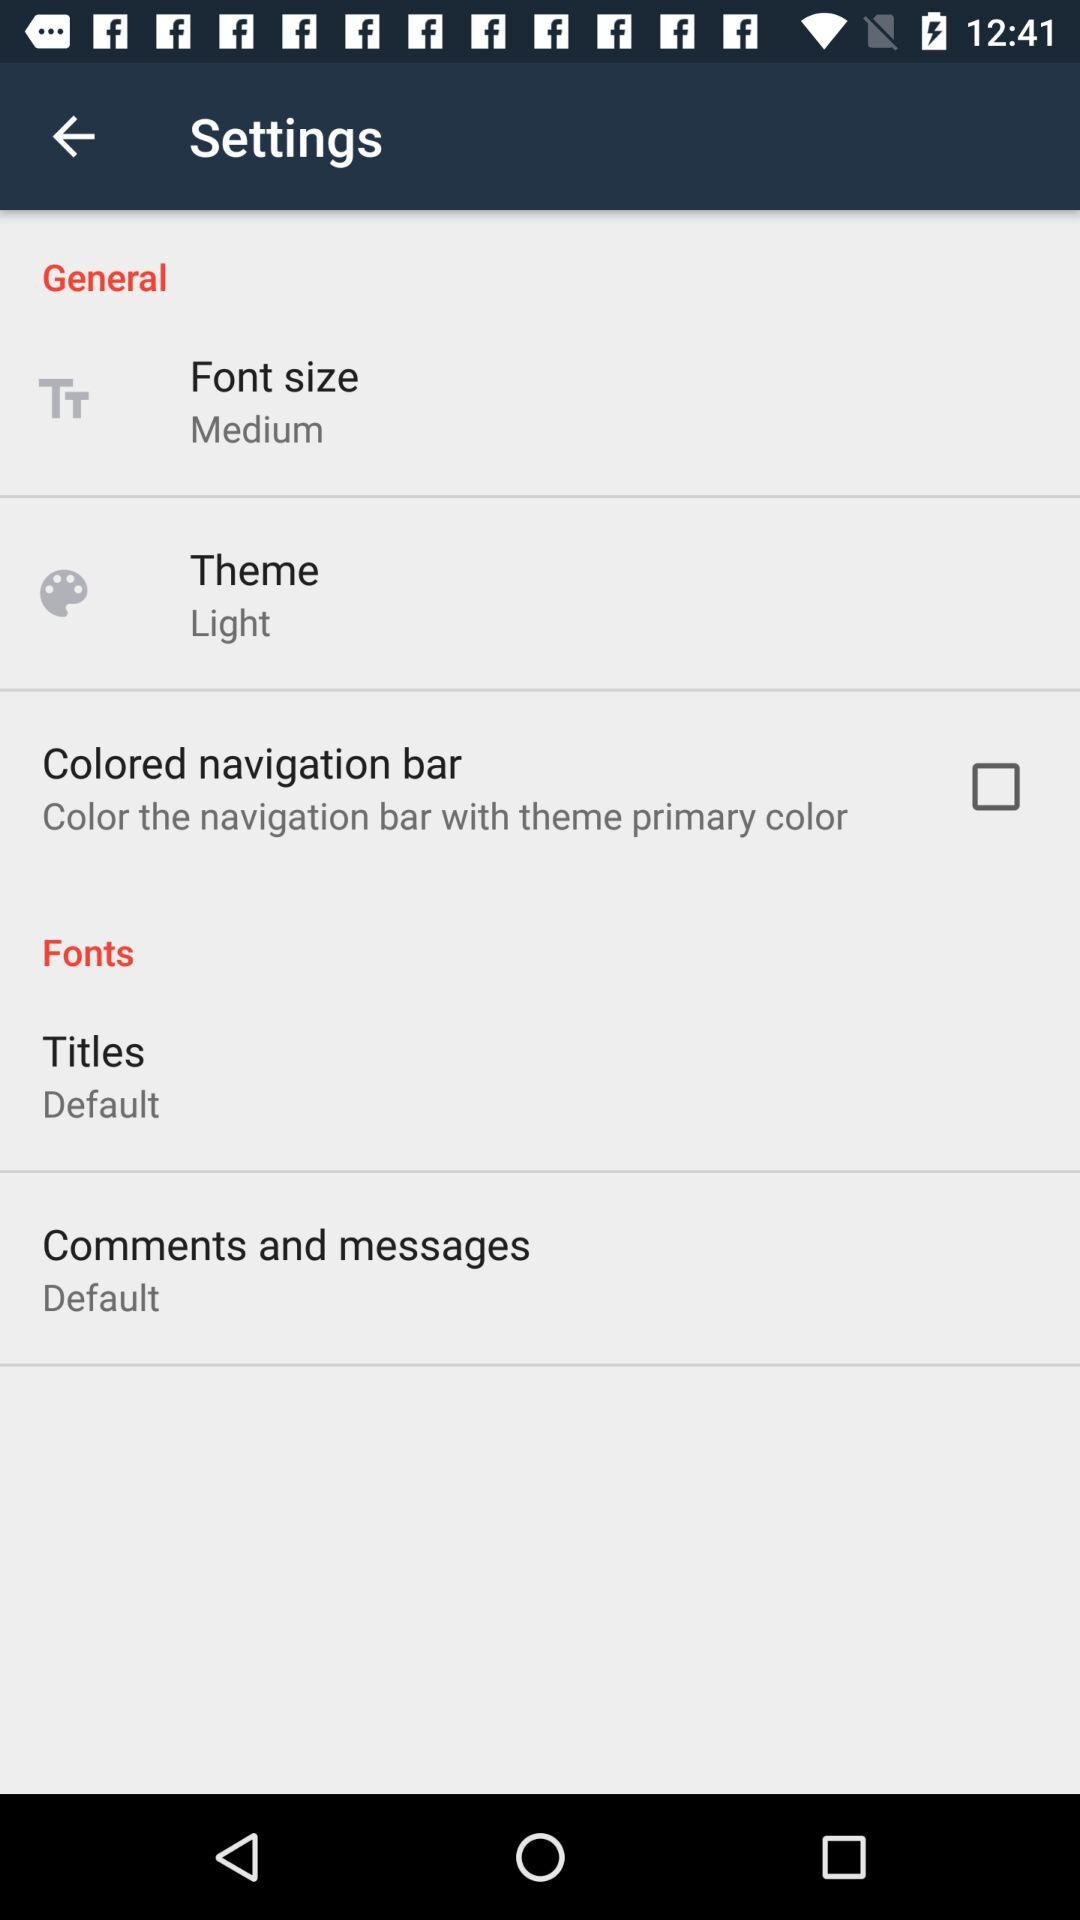How many items in the fonts section have a default theme?
Answer the question using a single word or phrase. 2 